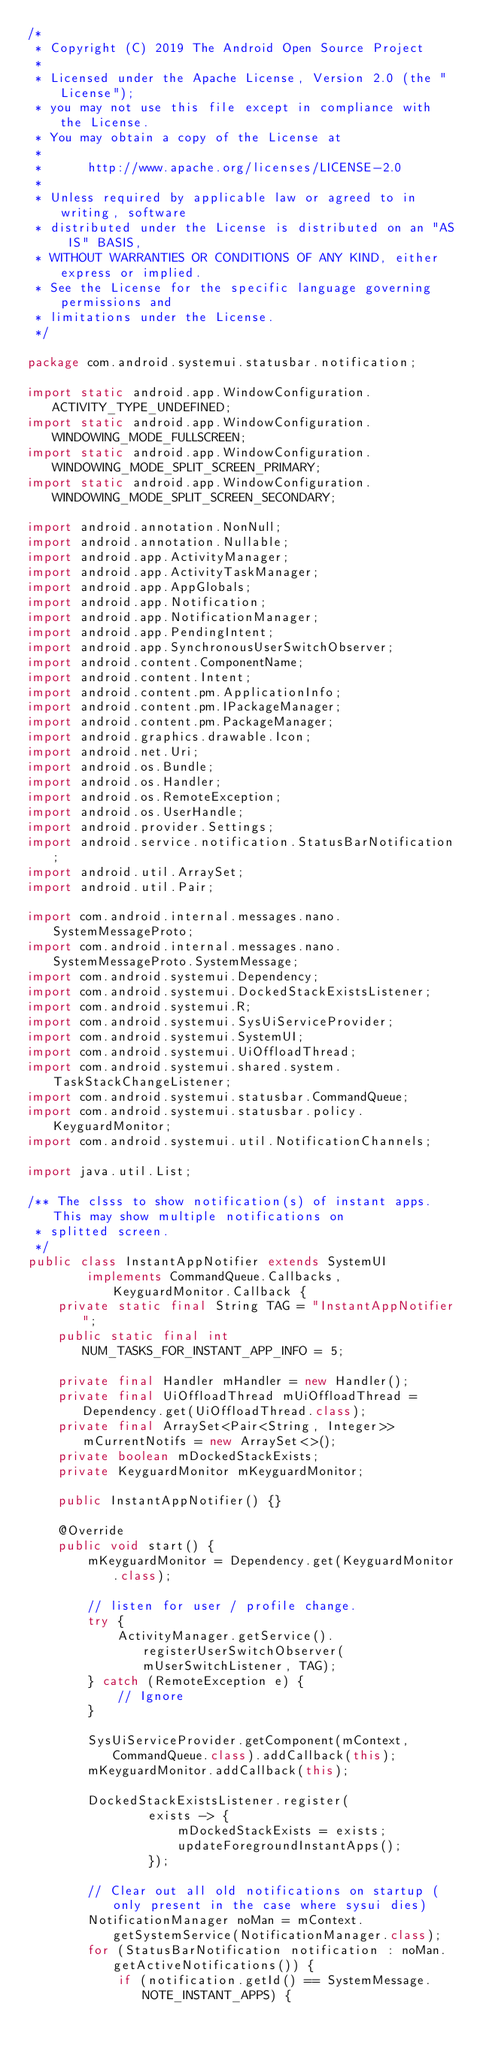<code> <loc_0><loc_0><loc_500><loc_500><_Java_>/*
 * Copyright (C) 2019 The Android Open Source Project
 *
 * Licensed under the Apache License, Version 2.0 (the "License");
 * you may not use this file except in compliance with the License.
 * You may obtain a copy of the License at
 *
 *      http://www.apache.org/licenses/LICENSE-2.0
 *
 * Unless required by applicable law or agreed to in writing, software
 * distributed under the License is distributed on an "AS IS" BASIS,
 * WITHOUT WARRANTIES OR CONDITIONS OF ANY KIND, either express or implied.
 * See the License for the specific language governing permissions and
 * limitations under the License.
 */

package com.android.systemui.statusbar.notification;

import static android.app.WindowConfiguration.ACTIVITY_TYPE_UNDEFINED;
import static android.app.WindowConfiguration.WINDOWING_MODE_FULLSCREEN;
import static android.app.WindowConfiguration.WINDOWING_MODE_SPLIT_SCREEN_PRIMARY;
import static android.app.WindowConfiguration.WINDOWING_MODE_SPLIT_SCREEN_SECONDARY;

import android.annotation.NonNull;
import android.annotation.Nullable;
import android.app.ActivityManager;
import android.app.ActivityTaskManager;
import android.app.AppGlobals;
import android.app.Notification;
import android.app.NotificationManager;
import android.app.PendingIntent;
import android.app.SynchronousUserSwitchObserver;
import android.content.ComponentName;
import android.content.Intent;
import android.content.pm.ApplicationInfo;
import android.content.pm.IPackageManager;
import android.content.pm.PackageManager;
import android.graphics.drawable.Icon;
import android.net.Uri;
import android.os.Bundle;
import android.os.Handler;
import android.os.RemoteException;
import android.os.UserHandle;
import android.provider.Settings;
import android.service.notification.StatusBarNotification;
import android.util.ArraySet;
import android.util.Pair;

import com.android.internal.messages.nano.SystemMessageProto;
import com.android.internal.messages.nano.SystemMessageProto.SystemMessage;
import com.android.systemui.Dependency;
import com.android.systemui.DockedStackExistsListener;
import com.android.systemui.R;
import com.android.systemui.SysUiServiceProvider;
import com.android.systemui.SystemUI;
import com.android.systemui.UiOffloadThread;
import com.android.systemui.shared.system.TaskStackChangeListener;
import com.android.systemui.statusbar.CommandQueue;
import com.android.systemui.statusbar.policy.KeyguardMonitor;
import com.android.systemui.util.NotificationChannels;

import java.util.List;

/** The clsss to show notification(s) of instant apps. This may show multiple notifications on
 * splitted screen.
 */
public class InstantAppNotifier extends SystemUI
        implements CommandQueue.Callbacks, KeyguardMonitor.Callback {
    private static final String TAG = "InstantAppNotifier";
    public static final int NUM_TASKS_FOR_INSTANT_APP_INFO = 5;

    private final Handler mHandler = new Handler();
    private final UiOffloadThread mUiOffloadThread = Dependency.get(UiOffloadThread.class);
    private final ArraySet<Pair<String, Integer>> mCurrentNotifs = new ArraySet<>();
    private boolean mDockedStackExists;
    private KeyguardMonitor mKeyguardMonitor;

    public InstantAppNotifier() {}

    @Override
    public void start() {
        mKeyguardMonitor = Dependency.get(KeyguardMonitor.class);

        // listen for user / profile change.
        try {
            ActivityManager.getService().registerUserSwitchObserver(mUserSwitchListener, TAG);
        } catch (RemoteException e) {
            // Ignore
        }

        SysUiServiceProvider.getComponent(mContext, CommandQueue.class).addCallback(this);
        mKeyguardMonitor.addCallback(this);

        DockedStackExistsListener.register(
                exists -> {
                    mDockedStackExists = exists;
                    updateForegroundInstantApps();
                });

        // Clear out all old notifications on startup (only present in the case where sysui dies)
        NotificationManager noMan = mContext.getSystemService(NotificationManager.class);
        for (StatusBarNotification notification : noMan.getActiveNotifications()) {
            if (notification.getId() == SystemMessage.NOTE_INSTANT_APPS) {</code> 